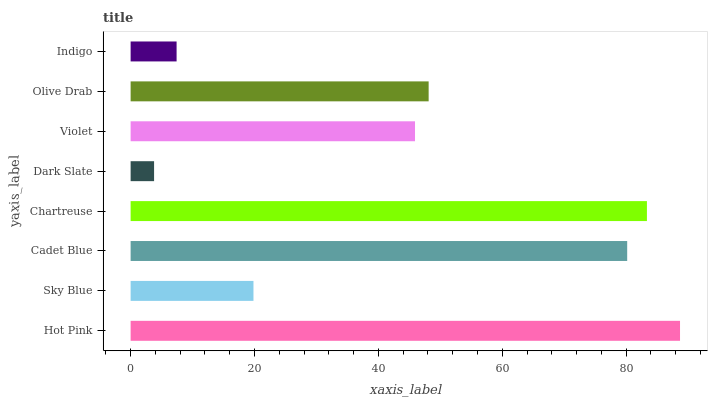Is Dark Slate the minimum?
Answer yes or no. Yes. Is Hot Pink the maximum?
Answer yes or no. Yes. Is Sky Blue the minimum?
Answer yes or no. No. Is Sky Blue the maximum?
Answer yes or no. No. Is Hot Pink greater than Sky Blue?
Answer yes or no. Yes. Is Sky Blue less than Hot Pink?
Answer yes or no. Yes. Is Sky Blue greater than Hot Pink?
Answer yes or no. No. Is Hot Pink less than Sky Blue?
Answer yes or no. No. Is Olive Drab the high median?
Answer yes or no. Yes. Is Violet the low median?
Answer yes or no. Yes. Is Hot Pink the high median?
Answer yes or no. No. Is Olive Drab the low median?
Answer yes or no. No. 